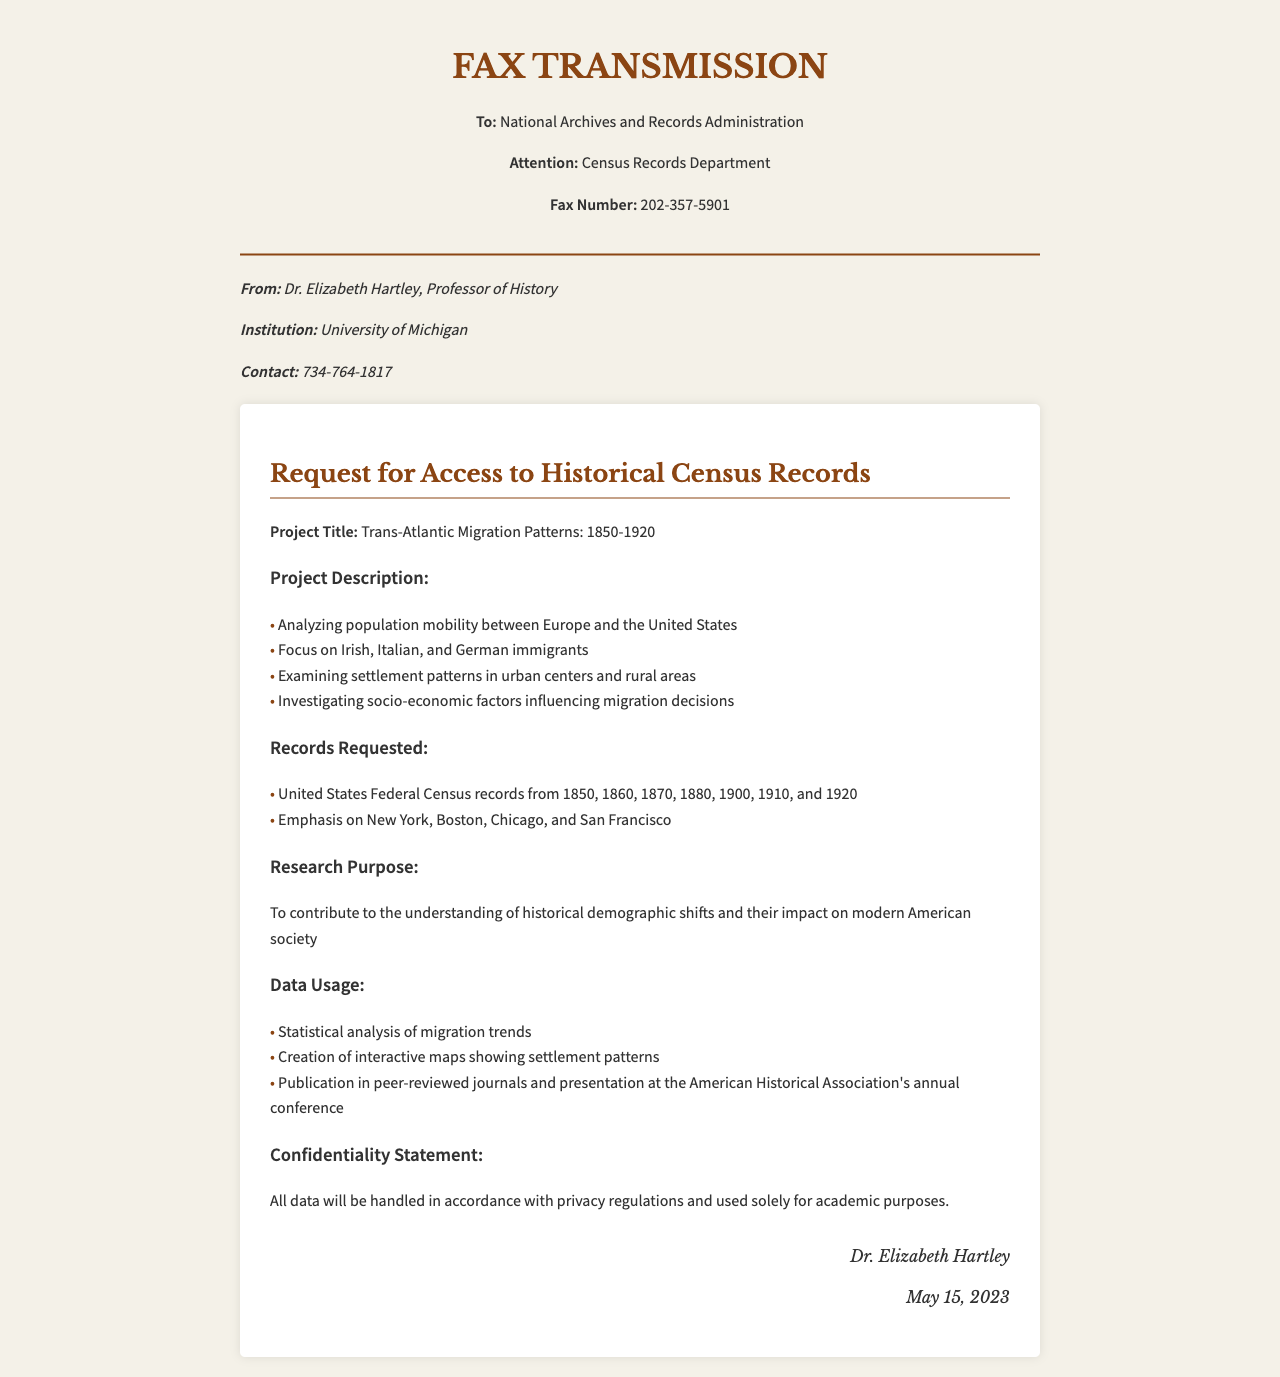What is the project title? The project title is stated at the beginning of the project description section in the document.
Answer: Trans-Atlantic Migration Patterns: 1850-1920 Who is the sender of the fax? The sender is listed at the top of the document, under sender information.
Answer: Dr. Elizabeth Hartley Which years of the United States Federal Census records are requested? The years are listed in the records requested section and include multiple specific years.
Answer: 1850, 1860, 1870, 1880, 1900, 1910, 1920 What is the primary focus of the research? The focus is detailed in the project description and sums up specific demographic groups.
Answer: Irish, Italian, and German immigrants What institution is Dr. Elizabeth Hartley affiliated with? The institution is mentioned in the sender information section of the fax.
Answer: University of Michigan What will the data be used for? The usage of data is outlined in the data usage section, explaining the purposes of analysis and publication.
Answer: Statistical analysis of migration trends What is the confidentiality statement related to? The confidentiality statement addresses how the data will be handled, as mentioned in the corresponding section.
Answer: Privacy regulations In which cities does the researcher emphasize for settlement patterns? The specific cities are listed in the records requested section.
Answer: New York, Boston, Chicago, and San Francisco What is the contact number for Dr. Elizabeth Hartley? The contact number is provided in the sender information section.
Answer: 734-764-1817 